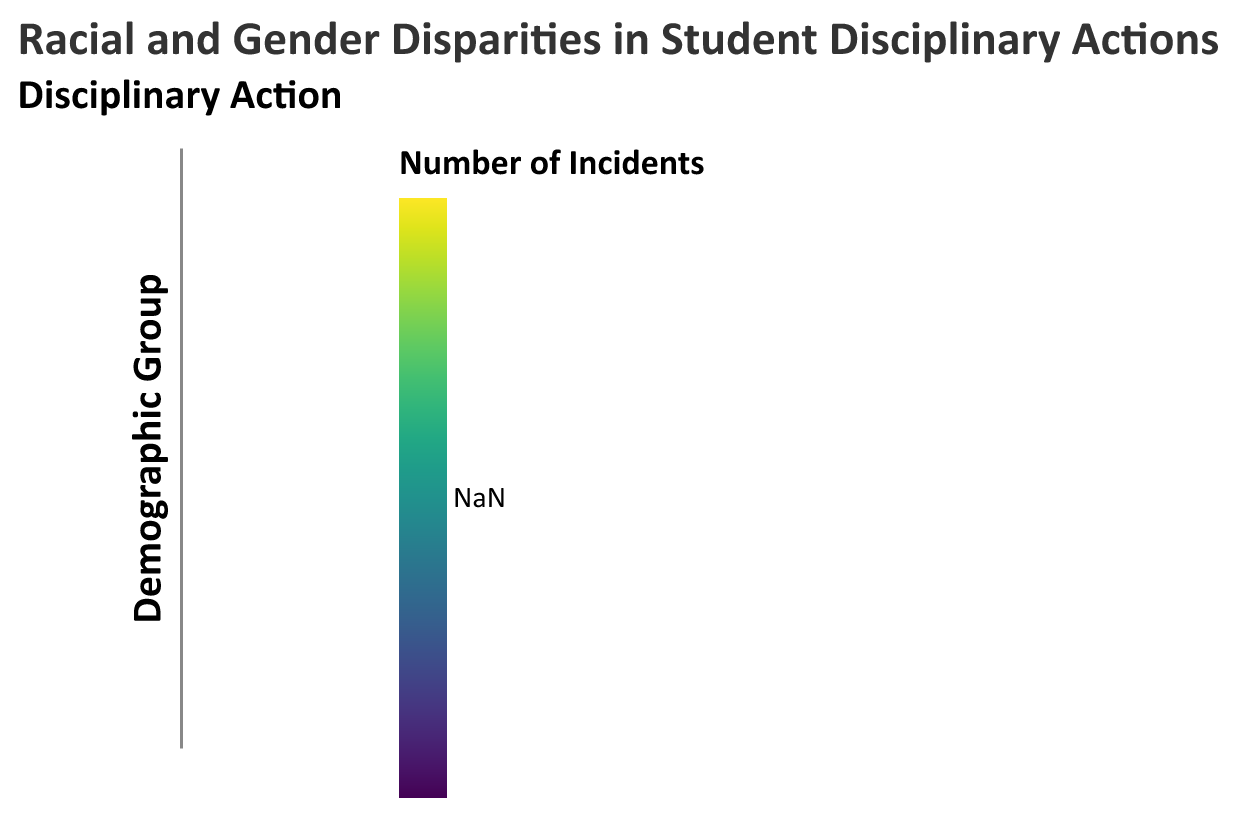What is the highest number of out-of-school suspensions recorded for African American females in any district? Look at the color intensity for "Out-School Suspension" for "African American Females" across all districts and identify the one with the highest value. In New York City, it's 13.
Answer: 13 Which group in Los Angeles has the lowest in-school suspension rate? Compare the color intensities for "In-School Suspension" in Los Angeles. "White Females" has the lowest rate with a value of 4.
Answer: White Females In which district are expulsions for White Males higher than those for White Females? Cross-reference the expulsion values for "White Males" and "White Females" across all districts. They are equal (0) in all districts.
Answer: None Calculate the total number of expulsions for African American males across all districts. Sum the expulsion values for "African American Males" from each district: 3 (Los Angeles) + 4 (New York City) + 3 (Chicago) = 10.
Answer: 10 Which district has the highest number of in-school suspensions for White Males? Compare the in-school suspension values for "White Males" across all districts. New York City's value of 7 is the highest.
Answer: New York City What is the difference in the number of out-of-school suspensions between African American Males and African American Females in Chicago? Subtract the number of out-of-school suspensions for "African American Females" from that for "African American Males" in Chicago: 17 - 11 = 6.
Answer: 6 Which demographic group in New York City has the highest overall number of disciplinary actions (sum of all types of suspensions and expulsions)? Combine the values for all types of disciplinary actions for each group in New York City. "African American Males" have 16 + 20 + 4 = 40 incidents, the highest.
Answer: African American Males 